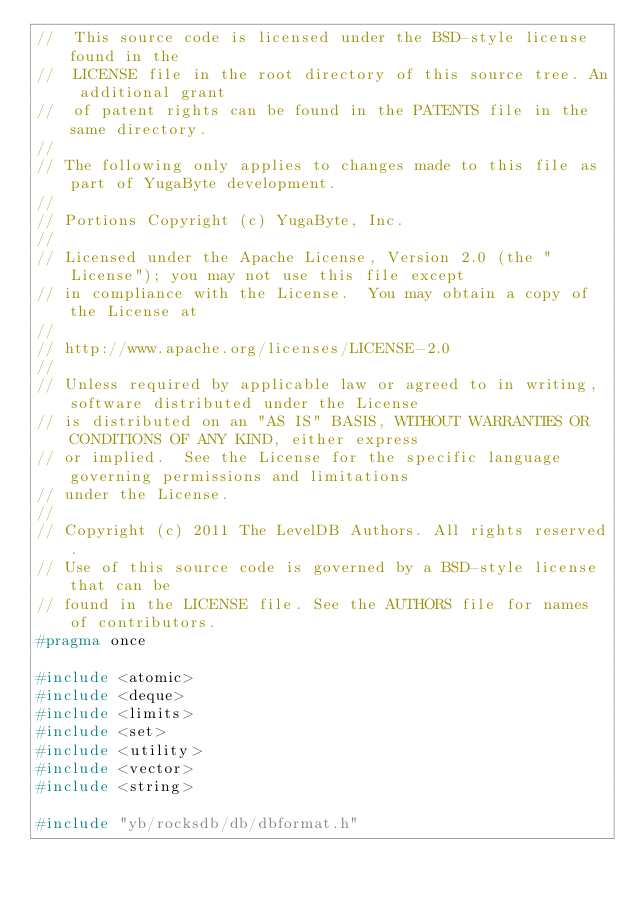<code> <loc_0><loc_0><loc_500><loc_500><_C_>//  This source code is licensed under the BSD-style license found in the
//  LICENSE file in the root directory of this source tree. An additional grant
//  of patent rights can be found in the PATENTS file in the same directory.
//
// The following only applies to changes made to this file as part of YugaByte development.
//
// Portions Copyright (c) YugaByte, Inc.
//
// Licensed under the Apache License, Version 2.0 (the "License"); you may not use this file except
// in compliance with the License.  You may obtain a copy of the License at
//
// http://www.apache.org/licenses/LICENSE-2.0
//
// Unless required by applicable law or agreed to in writing, software distributed under the License
// is distributed on an "AS IS" BASIS, WITHOUT WARRANTIES OR CONDITIONS OF ANY KIND, either express
// or implied.  See the License for the specific language governing permissions and limitations
// under the License.
//
// Copyright (c) 2011 The LevelDB Authors. All rights reserved.
// Use of this source code is governed by a BSD-style license that can be
// found in the LICENSE file. See the AUTHORS file for names of contributors.
#pragma once

#include <atomic>
#include <deque>
#include <limits>
#include <set>
#include <utility>
#include <vector>
#include <string>

#include "yb/rocksdb/db/dbformat.h"</code> 